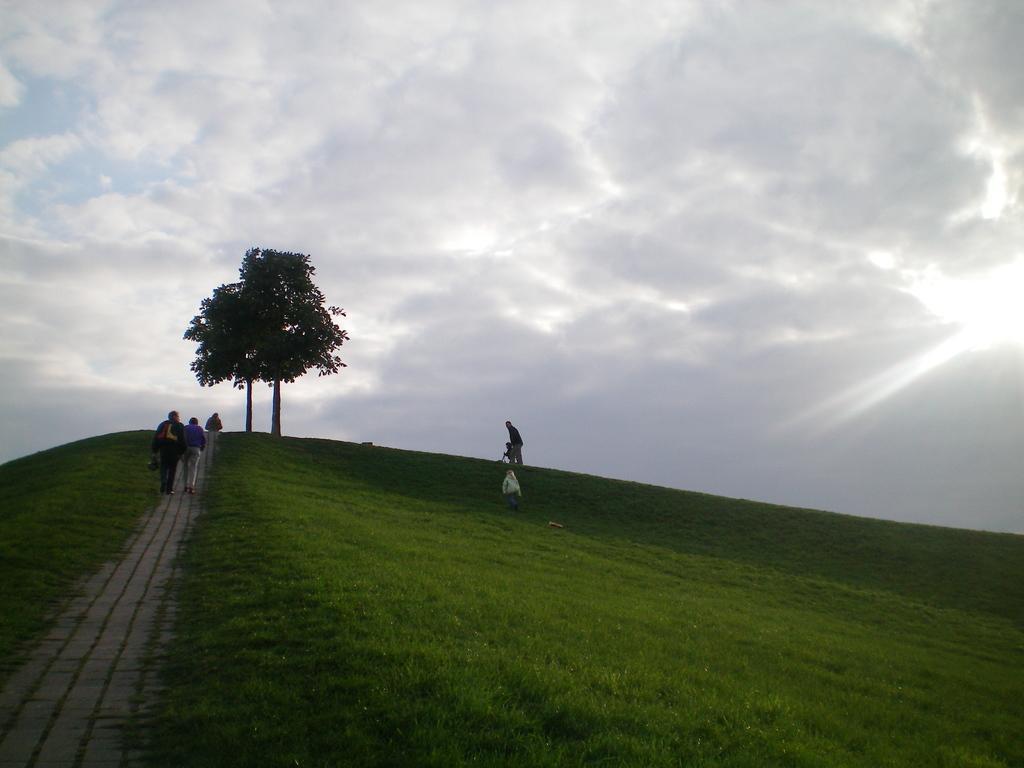In one or two sentences, can you explain what this image depicts? In this image I can see few people are walking and few are holding bags. I can see few trees and green grass. The sky is in white and blue color. 